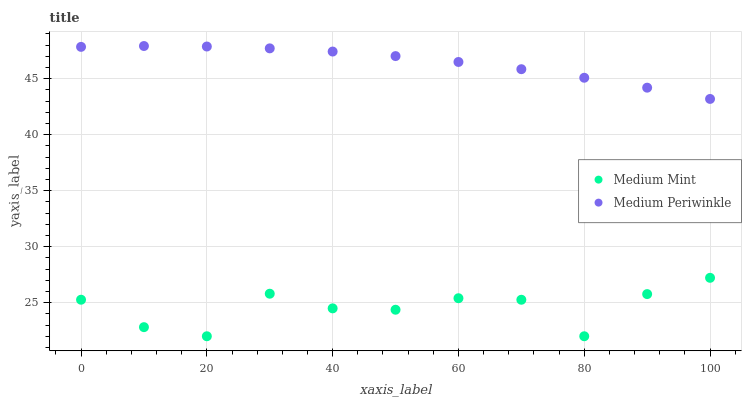Does Medium Mint have the minimum area under the curve?
Answer yes or no. Yes. Does Medium Periwinkle have the maximum area under the curve?
Answer yes or no. Yes. Does Medium Periwinkle have the minimum area under the curve?
Answer yes or no. No. Is Medium Periwinkle the smoothest?
Answer yes or no. Yes. Is Medium Mint the roughest?
Answer yes or no. Yes. Is Medium Periwinkle the roughest?
Answer yes or no. No. Does Medium Mint have the lowest value?
Answer yes or no. Yes. Does Medium Periwinkle have the lowest value?
Answer yes or no. No. Does Medium Periwinkle have the highest value?
Answer yes or no. Yes. Is Medium Mint less than Medium Periwinkle?
Answer yes or no. Yes. Is Medium Periwinkle greater than Medium Mint?
Answer yes or no. Yes. Does Medium Mint intersect Medium Periwinkle?
Answer yes or no. No. 